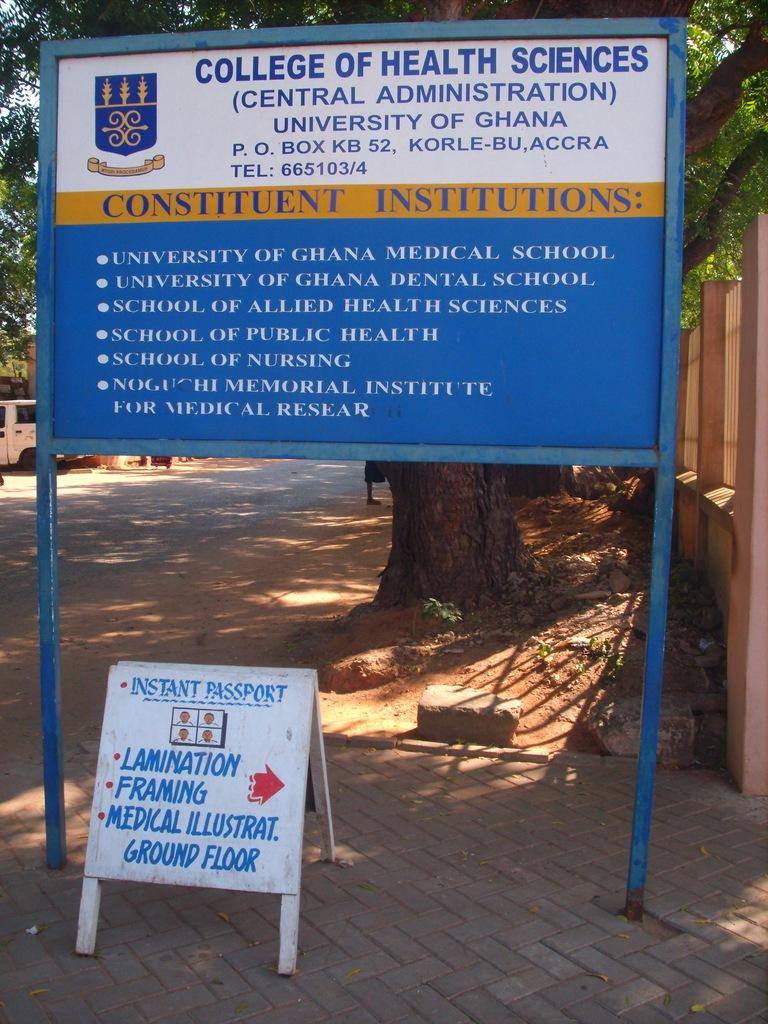What can be seen on the ground in the image? There are two sign boards with text in the image. How are the sign boards positioned in the image? The sign boards are placed on the ground. What is visible in the background of the image? There is a wall, a vehicle parked on the road, and a group of trees in the background. What type of pet can be seen playing with scissors in the image? There is no pet or scissors present in the image. 